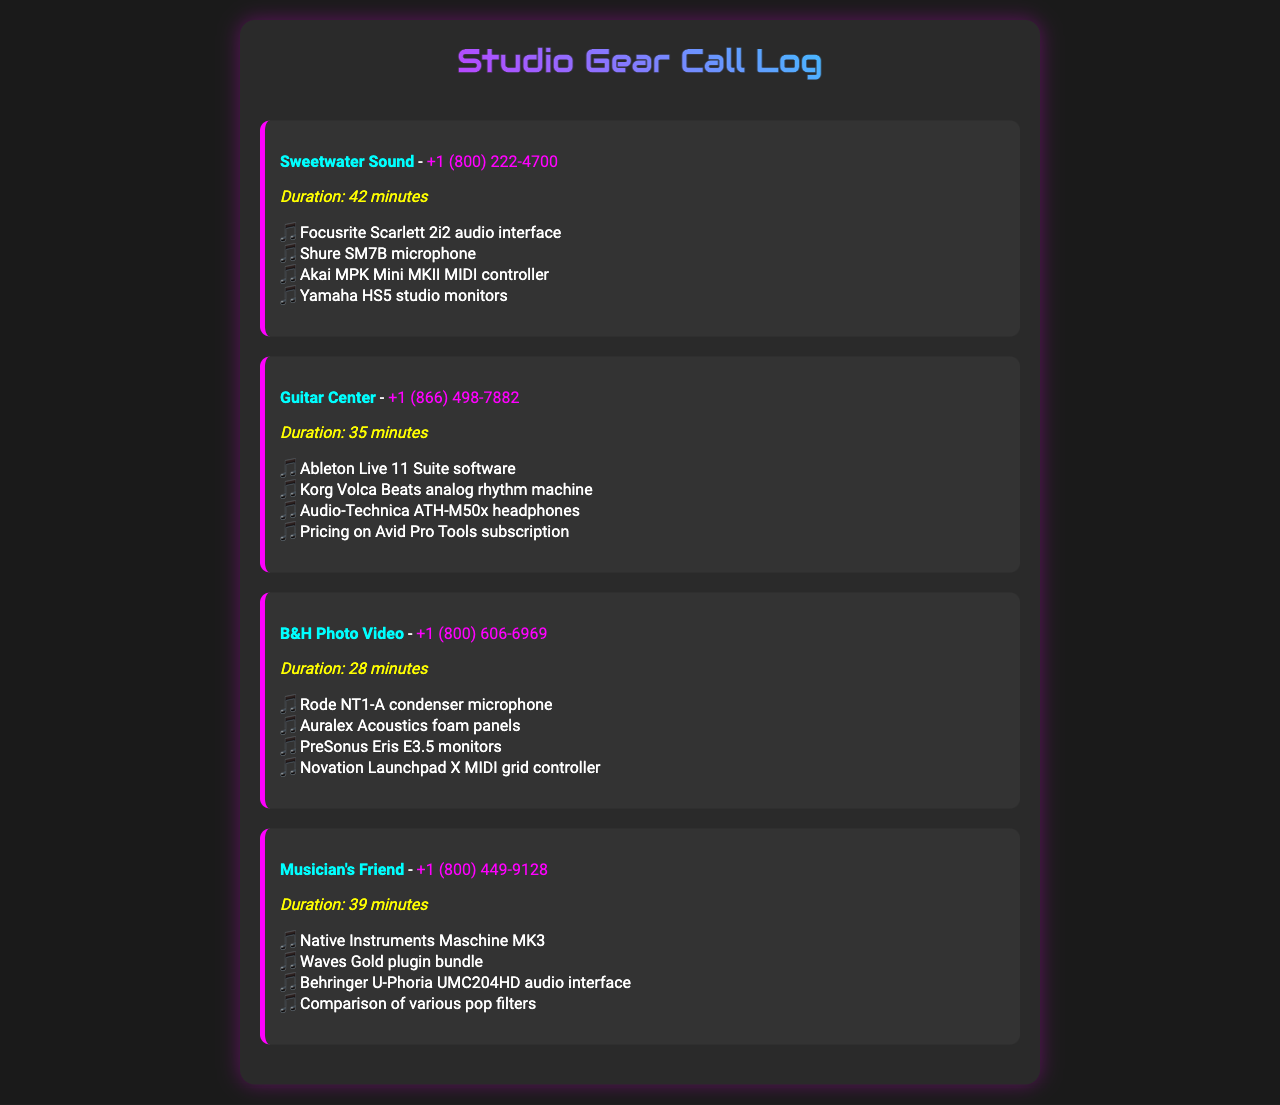What is the first supplier listed? The first supplier mentioned in the document is Sweetwater Sound.
Answer: Sweetwater Sound How long was the call with Guitar Center? The duration of the call with Guitar Center is provided in the document as 35 minutes.
Answer: 35 minutes Which microphone was discussed during calls? The document lists several microphones, specifically the Shure SM7B and Rode NT1-A.
Answer: Shure SM7B How many items were discussed in the call with B&H Photo Video? The document shows that four items were discussed during the call with B&H Photo Video.
Answer: 4 What audio interface was mentioned in the call with Musician's Friend? The document states that the Behringer U-Phoria UMC204HD audio interface was discussed.
Answer: Behringer U-Phoria UMC204HD Which supplier offered Ableton Live 11 Suite? The document indicates that Ableton Live 11 Suite was offered by Guitar Center.
Answer: Guitar Center What type of product is mentioned in all calls? Each call covers studio gear, which is the central theme of the document.
Answer: Studio gear Which call lasted the longest? The document reveals that the call with Sweetwater Sound lasted the longest at 42 minutes.
Answer: 42 minutes What was the total number of calls recorded? The document presents a total of four calls listed in the call log section.
Answer: 4 